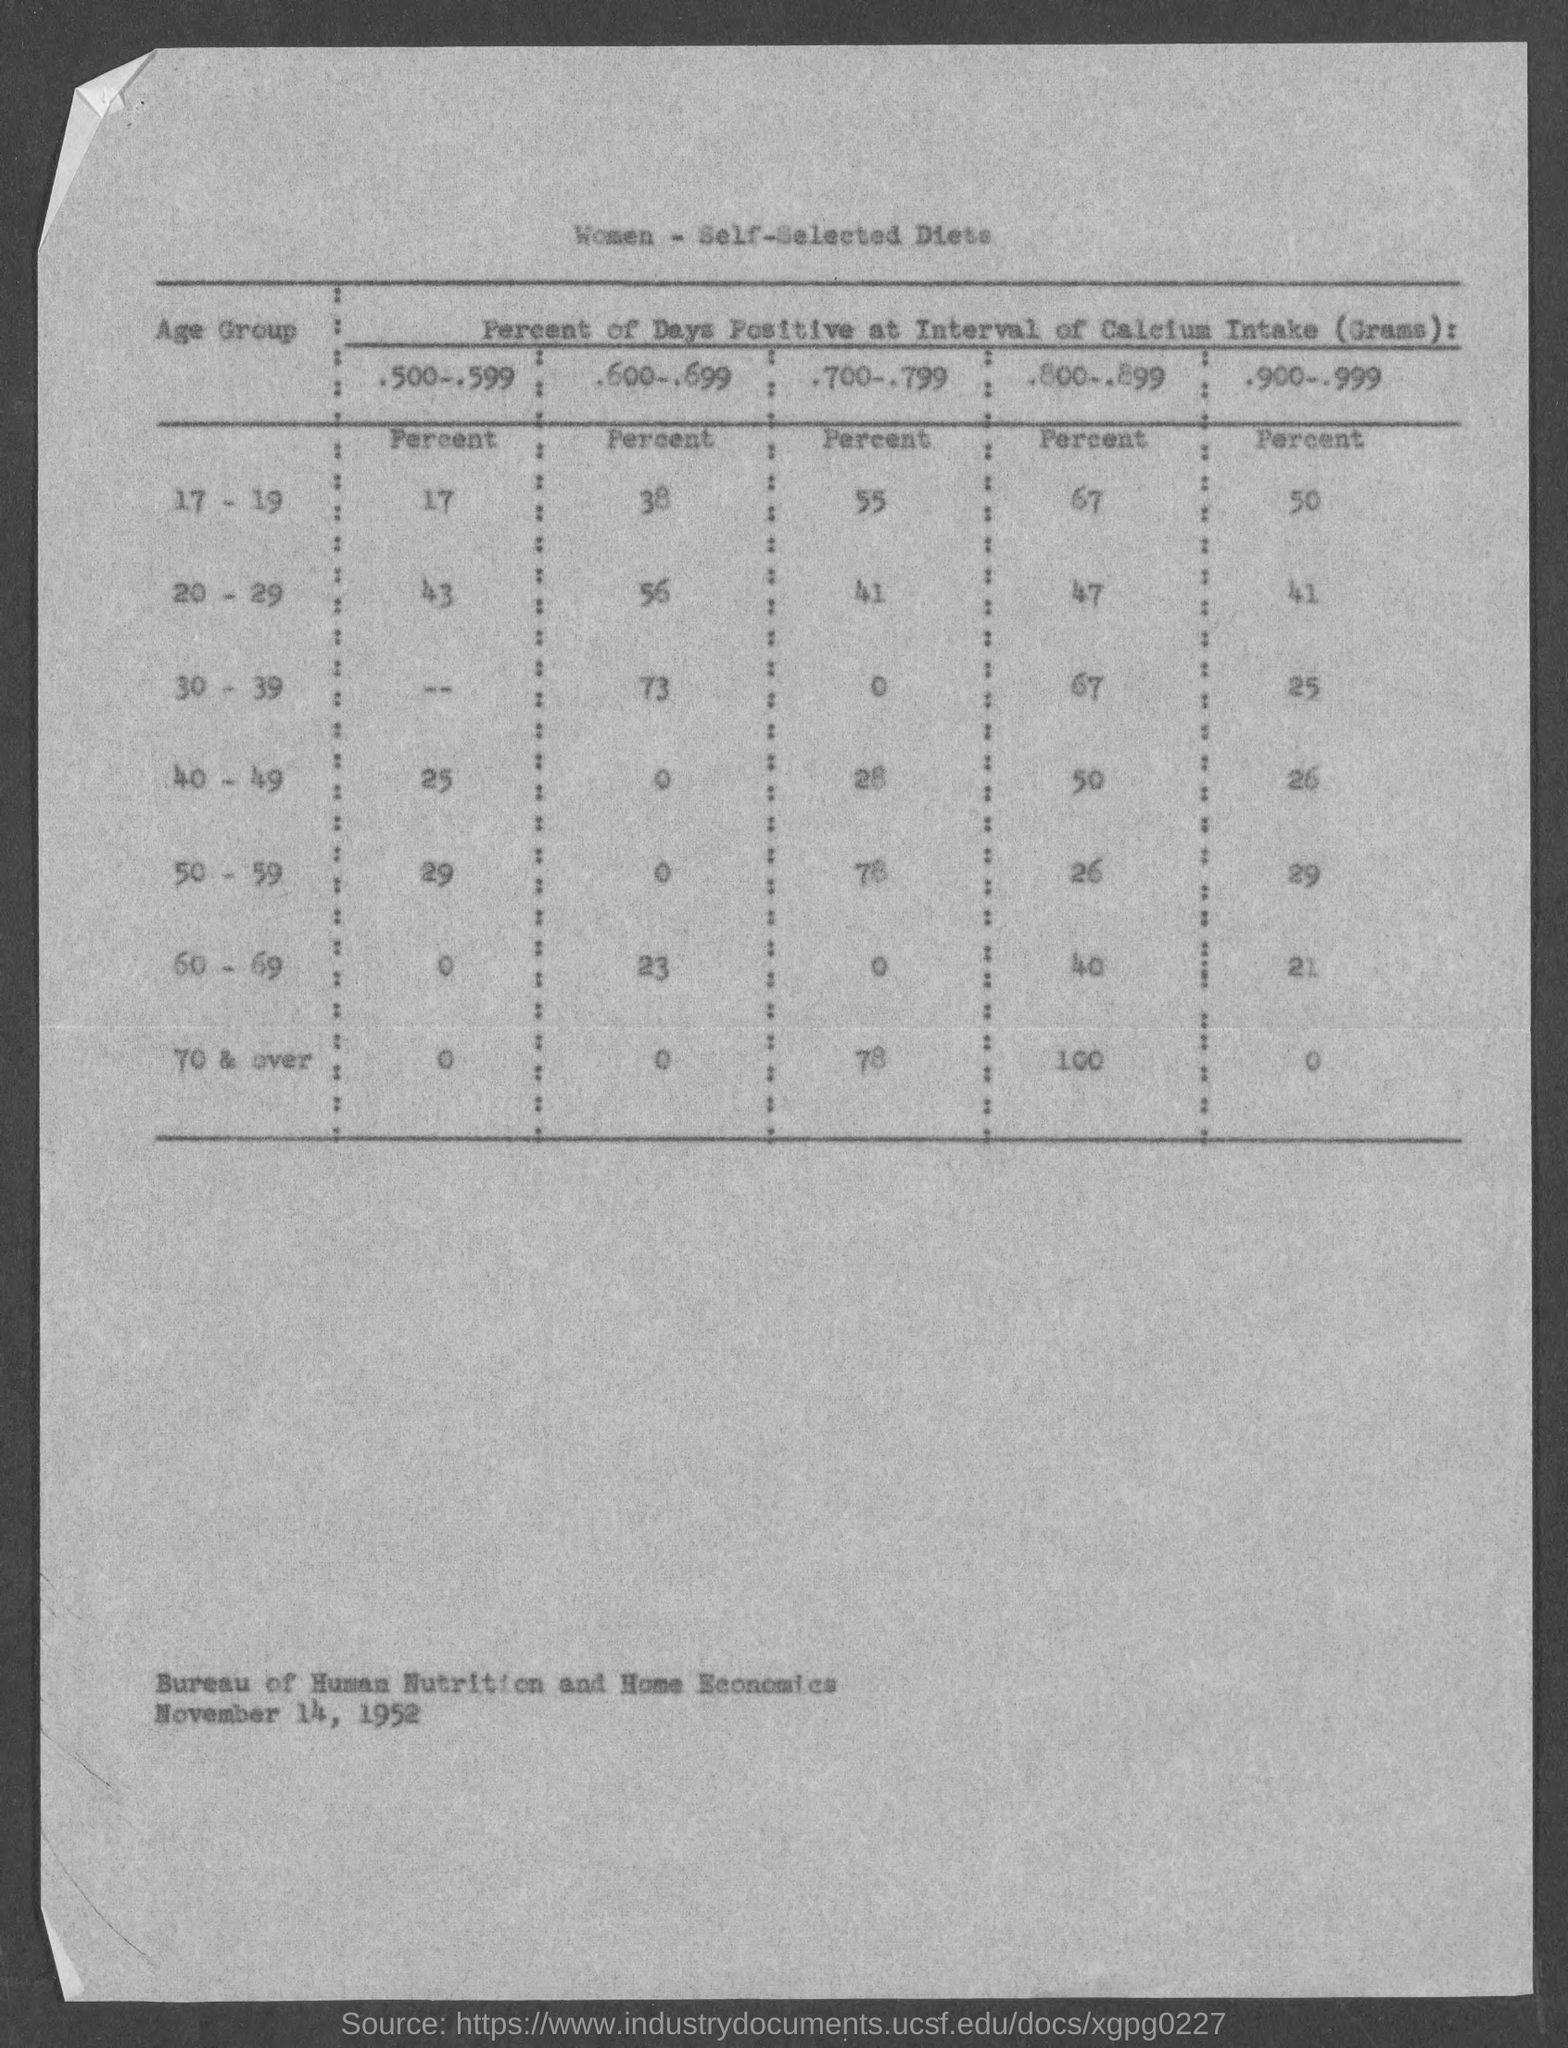What is the table title?
Your answer should be very brief. Women - self-selected diets. What percent of days in the age group 17-19 is under .500-.599?
Your answer should be very brief. 17. 